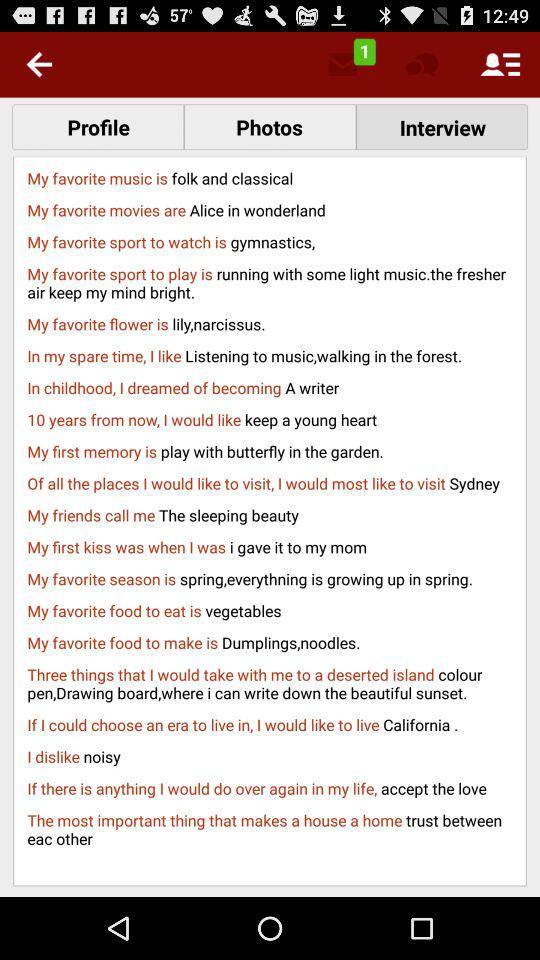Which flower is my favorite? Your favorite flower is the lily, Narcissus. 